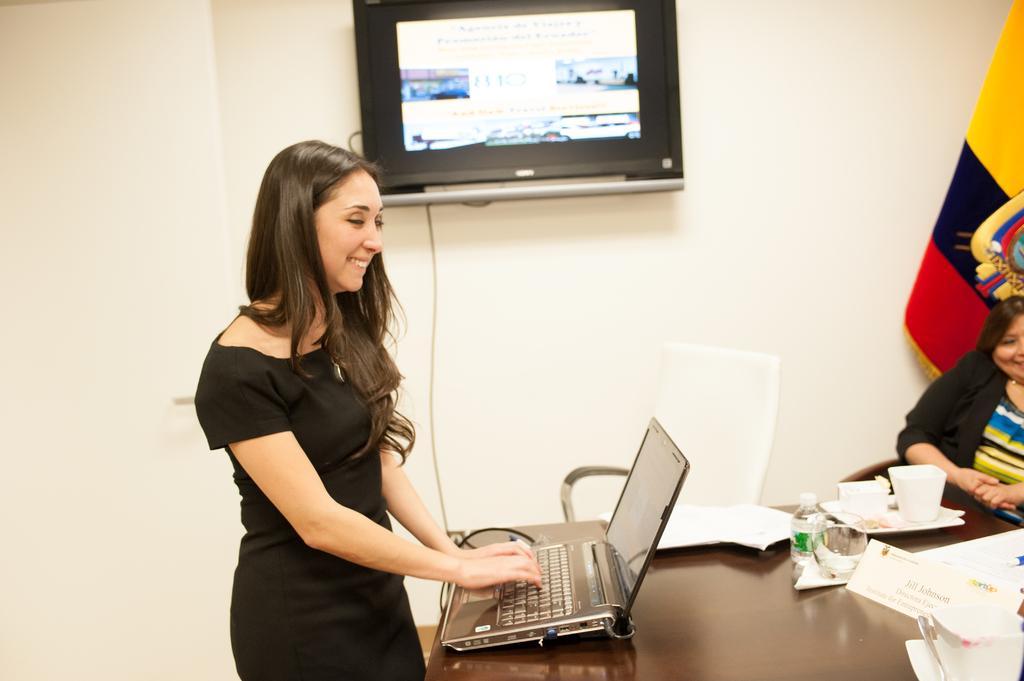Can you describe this image briefly? The women wearing black dress is operating laptop which is placed on the table and there is a television beside and there is another person sitting in the right corner. 